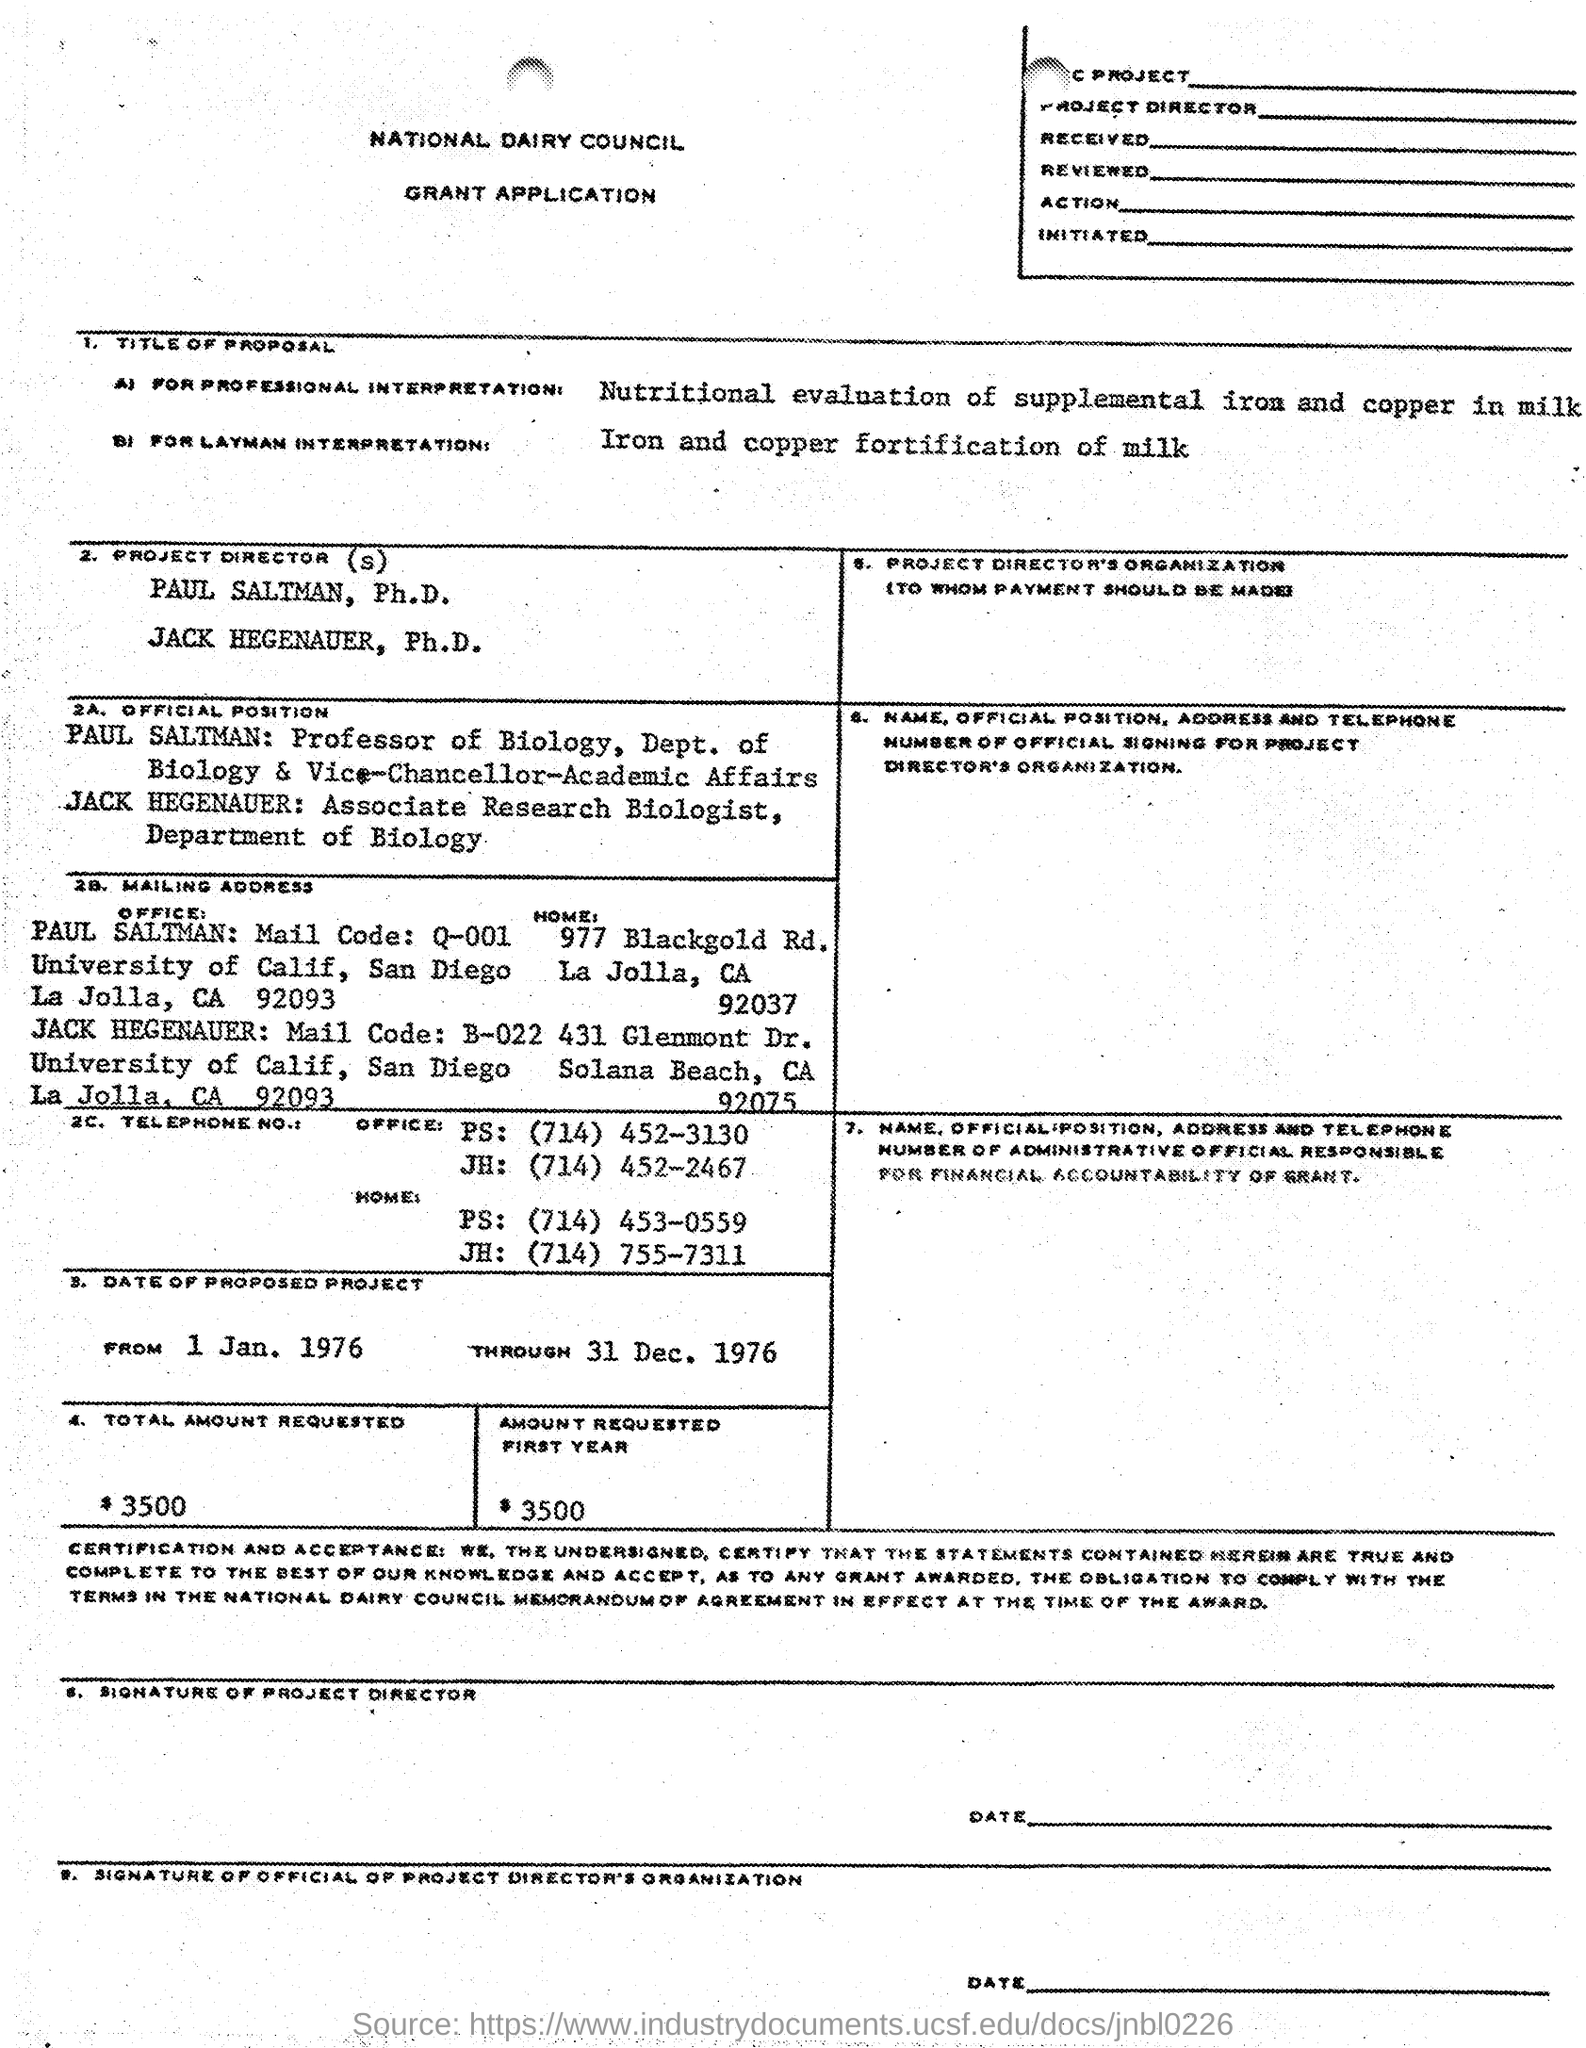Which council this application belongs to ?
Your answer should be compact. National Dairy Council. Who is the professor of biology ?
Provide a short and direct response. Paul Saltman. What is the saltman mail code ?
Provide a short and direct response. Q-001. What is the office telephone number of ps ?
Make the answer very short. (714) 452-3130. 